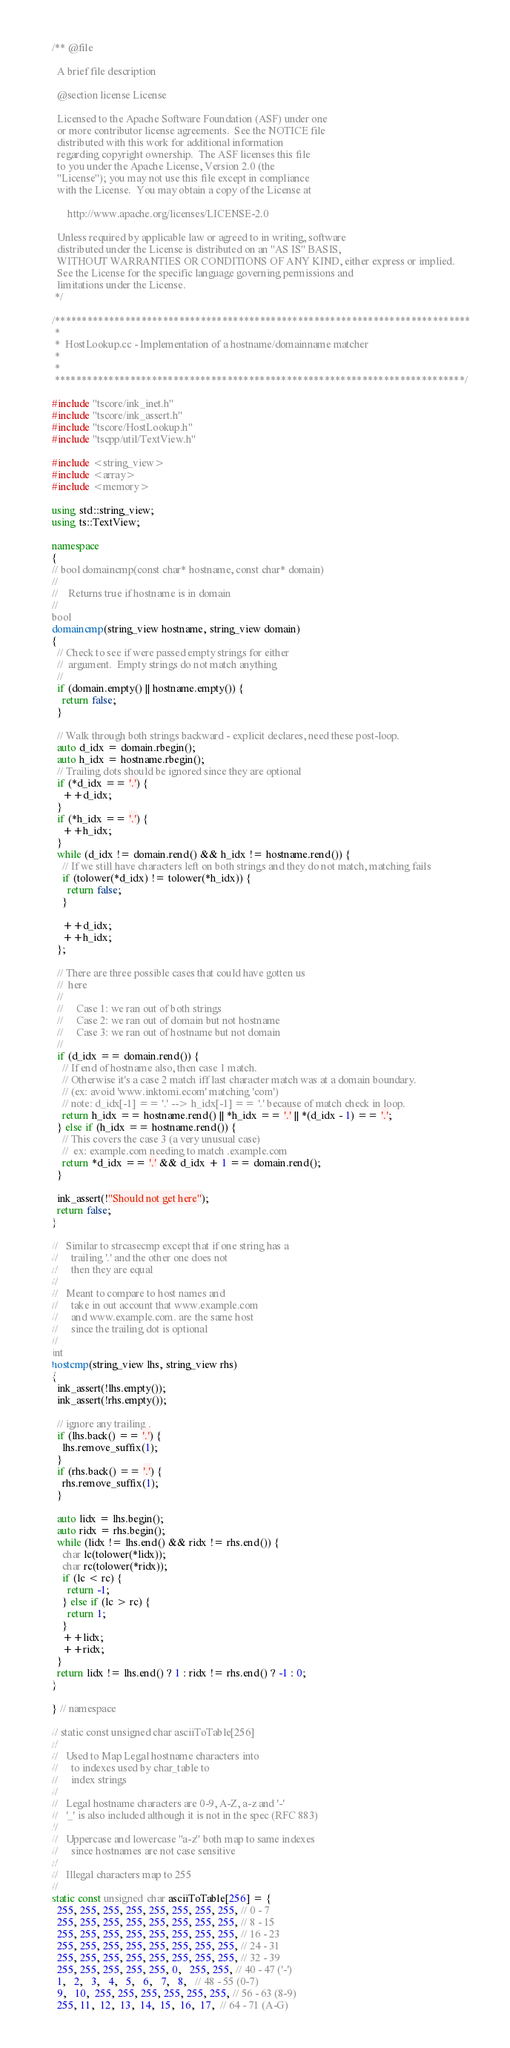<code> <loc_0><loc_0><loc_500><loc_500><_C++_>/** @file

  A brief file description

  @section license License

  Licensed to the Apache Software Foundation (ASF) under one
  or more contributor license agreements.  See the NOTICE file
  distributed with this work for additional information
  regarding copyright ownership.  The ASF licenses this file
  to you under the Apache License, Version 2.0 (the
  "License"); you may not use this file except in compliance
  with the License.  You may obtain a copy of the License at

      http://www.apache.org/licenses/LICENSE-2.0

  Unless required by applicable law or agreed to in writing, software
  distributed under the License is distributed on an "AS IS" BASIS,
  WITHOUT WARRANTIES OR CONDITIONS OF ANY KIND, either express or implied.
  See the License for the specific language governing permissions and
  limitations under the License.
 */

/*****************************************************************************
 *
 *  HostLookup.cc - Implementation of a hostname/domainname matcher
 *
 *
 ****************************************************************************/

#include "tscore/ink_inet.h"
#include "tscore/ink_assert.h"
#include "tscore/HostLookup.h"
#include "tscpp/util/TextView.h"

#include <string_view>
#include <array>
#include <memory>

using std::string_view;
using ts::TextView;

namespace
{
// bool domaincmp(const char* hostname, const char* domain)
//
//    Returns true if hostname is in domain
//
bool
domaincmp(string_view hostname, string_view domain)
{
  // Check to see if were passed empty strings for either
  //  argument.  Empty strings do not match anything
  //
  if (domain.empty() || hostname.empty()) {
    return false;
  }

  // Walk through both strings backward - explicit declares, need these post-loop.
  auto d_idx = domain.rbegin();
  auto h_idx = hostname.rbegin();
  // Trailing dots should be ignored since they are optional
  if (*d_idx == '.') {
    ++d_idx;
  }
  if (*h_idx == '.') {
    ++h_idx;
  }
  while (d_idx != domain.rend() && h_idx != hostname.rend()) {
    // If we still have characters left on both strings and they do not match, matching fails
    if (tolower(*d_idx) != tolower(*h_idx)) {
      return false;
    }

    ++d_idx;
    ++h_idx;
  };

  // There are three possible cases that could have gotten us
  //  here
  //
  //     Case 1: we ran out of both strings
  //     Case 2: we ran out of domain but not hostname
  //     Case 3: we ran out of hostname but not domain
  //
  if (d_idx == domain.rend()) {
    // If end of hostname also, then case 1 match.
    // Otherwise it's a case 2 match iff last character match was at a domain boundary.
    // (ex: avoid 'www.inktomi.ecom' matching 'com')
    // note: d_idx[-1] == '.' --> h_idx[-1] == '.' because of match check in loop.
    return h_idx == hostname.rend() || *h_idx == '.' || *(d_idx - 1) == '.';
  } else if (h_idx == hostname.rend()) {
    // This covers the case 3 (a very unusual case)
    //  ex: example.com needing to match .example.com
    return *d_idx == '.' && d_idx + 1 == domain.rend();
  }

  ink_assert(!"Should not get here");
  return false;
}

//   Similar to strcasecmp except that if one string has a
//     trailing '.' and the other one does not
//     then they are equal
//
//   Meant to compare to host names and
//     take in out account that www.example.com
//     and www.example.com. are the same host
//     since the trailing dot is optional
//
int
hostcmp(string_view lhs, string_view rhs)
{
  ink_assert(!lhs.empty());
  ink_assert(!rhs.empty());

  // ignore any trailing .
  if (lhs.back() == '.') {
    lhs.remove_suffix(1);
  }
  if (rhs.back() == '.') {
    rhs.remove_suffix(1);
  }

  auto lidx = lhs.begin();
  auto ridx = rhs.begin();
  while (lidx != lhs.end() && ridx != rhs.end()) {
    char lc(tolower(*lidx));
    char rc(tolower(*ridx));
    if (lc < rc) {
      return -1;
    } else if (lc > rc) {
      return 1;
    }
    ++lidx;
    ++ridx;
  }
  return lidx != lhs.end() ? 1 : ridx != rhs.end() ? -1 : 0;
}

} // namespace

// static const unsigned char asciiToTable[256]
//
//   Used to Map Legal hostname characters into
//     to indexes used by char_table to
//     index strings
//
//   Legal hostname characters are 0-9, A-Z, a-z and '-'
//   '_' is also included although it is not in the spec (RFC 883)
//
//   Uppercase and lowercase "a-z" both map to same indexes
//     since hostnames are not case sensitive
//
//   Illegal characters map to 255
//
static const unsigned char asciiToTable[256] = {
  255, 255, 255, 255, 255, 255, 255, 255, // 0 - 7
  255, 255, 255, 255, 255, 255, 255, 255, // 8 - 15
  255, 255, 255, 255, 255, 255, 255, 255, // 16 - 23
  255, 255, 255, 255, 255, 255, 255, 255, // 24 - 31
  255, 255, 255, 255, 255, 255, 255, 255, // 32 - 39
  255, 255, 255, 255, 255, 0,   255, 255, // 40 - 47 ('-')
  1,   2,   3,   4,   5,   6,   7,   8,   // 48 - 55 (0-7)
  9,   10,  255, 255, 255, 255, 255, 255, // 56 - 63 (8-9)
  255, 11,  12,  13,  14,  15,  16,  17,  // 64 - 71 (A-G)</code> 